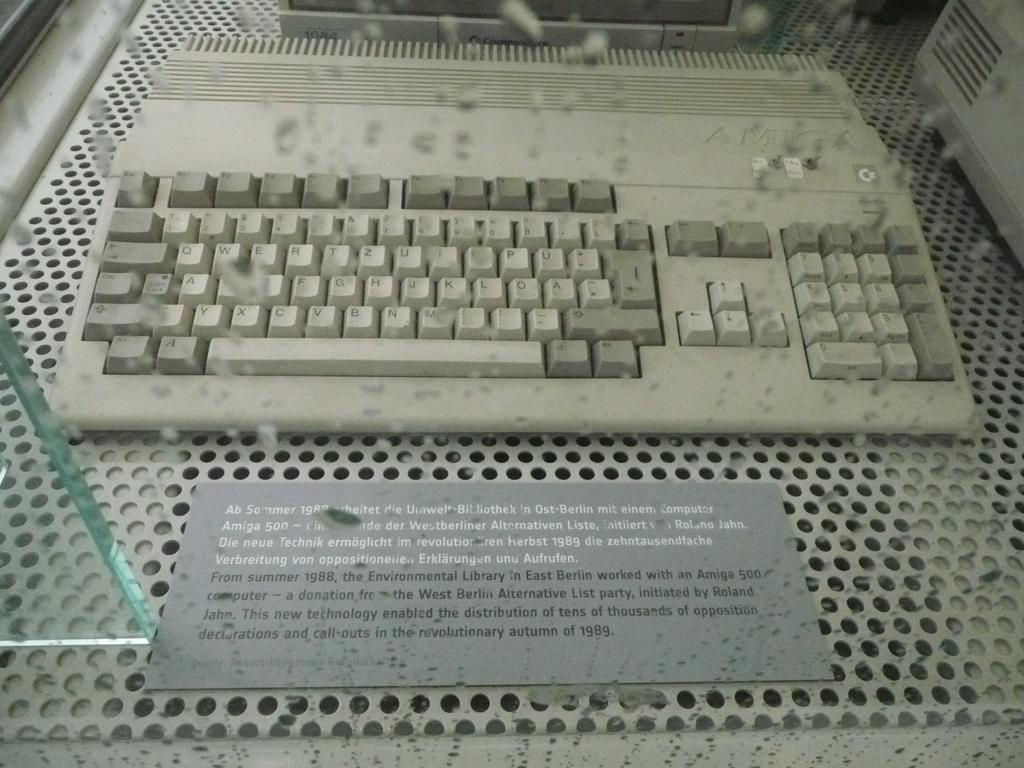<image>
Offer a succinct explanation of the picture presented. A keyboard on display in a museum that came out in 1989. 